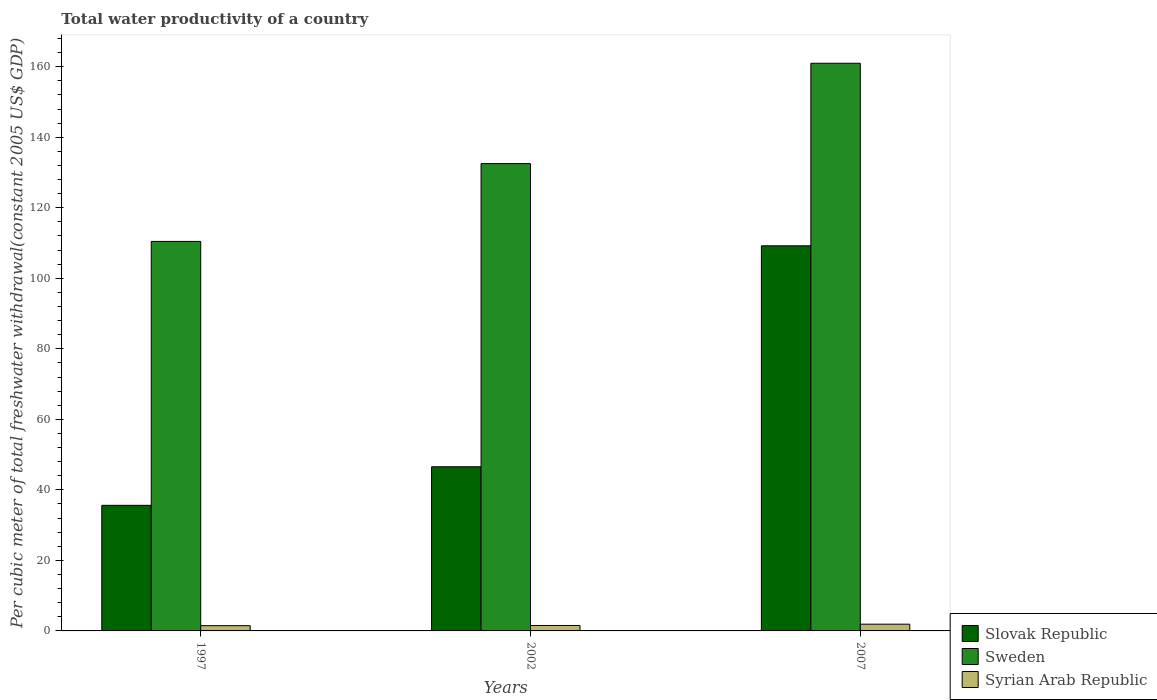How many different coloured bars are there?
Provide a short and direct response. 3. Are the number of bars on each tick of the X-axis equal?
Your answer should be compact. Yes. How many bars are there on the 1st tick from the left?
Ensure brevity in your answer.  3. How many bars are there on the 3rd tick from the right?
Make the answer very short. 3. What is the label of the 2nd group of bars from the left?
Your answer should be very brief. 2002. In how many cases, is the number of bars for a given year not equal to the number of legend labels?
Your answer should be very brief. 0. What is the total water productivity in Sweden in 2002?
Offer a very short reply. 132.53. Across all years, what is the maximum total water productivity in Slovak Republic?
Offer a terse response. 109.22. Across all years, what is the minimum total water productivity in Syrian Arab Republic?
Make the answer very short. 1.49. In which year was the total water productivity in Sweden maximum?
Your response must be concise. 2007. In which year was the total water productivity in Sweden minimum?
Your answer should be compact. 1997. What is the total total water productivity in Slovak Republic in the graph?
Your response must be concise. 191.39. What is the difference between the total water productivity in Slovak Republic in 1997 and that in 2007?
Ensure brevity in your answer.  -73.6. What is the difference between the total water productivity in Syrian Arab Republic in 1997 and the total water productivity in Sweden in 2002?
Your answer should be compact. -131.04. What is the average total water productivity in Syrian Arab Republic per year?
Your response must be concise. 1.65. In the year 2002, what is the difference between the total water productivity in Slovak Republic and total water productivity in Sweden?
Provide a short and direct response. -85.98. In how many years, is the total water productivity in Syrian Arab Republic greater than 80 US$?
Provide a short and direct response. 0. What is the ratio of the total water productivity in Slovak Republic in 1997 to that in 2002?
Make the answer very short. 0.77. Is the total water productivity in Slovak Republic in 1997 less than that in 2007?
Provide a short and direct response. Yes. Is the difference between the total water productivity in Slovak Republic in 1997 and 2002 greater than the difference between the total water productivity in Sweden in 1997 and 2002?
Provide a short and direct response. Yes. What is the difference between the highest and the second highest total water productivity in Syrian Arab Republic?
Keep it short and to the point. 0.37. What is the difference between the highest and the lowest total water productivity in Sweden?
Offer a terse response. 50.53. Is the sum of the total water productivity in Slovak Republic in 2002 and 2007 greater than the maximum total water productivity in Syrian Arab Republic across all years?
Make the answer very short. Yes. What does the 3rd bar from the right in 1997 represents?
Provide a succinct answer. Slovak Republic. How many years are there in the graph?
Provide a succinct answer. 3. What is the difference between two consecutive major ticks on the Y-axis?
Keep it short and to the point. 20. Are the values on the major ticks of Y-axis written in scientific E-notation?
Your answer should be very brief. No. Does the graph contain any zero values?
Ensure brevity in your answer.  No. Does the graph contain grids?
Keep it short and to the point. No. Where does the legend appear in the graph?
Your response must be concise. Bottom right. What is the title of the graph?
Offer a terse response. Total water productivity of a country. What is the label or title of the Y-axis?
Keep it short and to the point. Per cubic meter of total freshwater withdrawal(constant 2005 US$ GDP). What is the Per cubic meter of total freshwater withdrawal(constant 2005 US$ GDP) in Slovak Republic in 1997?
Make the answer very short. 35.62. What is the Per cubic meter of total freshwater withdrawal(constant 2005 US$ GDP) in Sweden in 1997?
Offer a very short reply. 110.46. What is the Per cubic meter of total freshwater withdrawal(constant 2005 US$ GDP) in Syrian Arab Republic in 1997?
Your answer should be compact. 1.49. What is the Per cubic meter of total freshwater withdrawal(constant 2005 US$ GDP) of Slovak Republic in 2002?
Your answer should be very brief. 46.55. What is the Per cubic meter of total freshwater withdrawal(constant 2005 US$ GDP) in Sweden in 2002?
Your answer should be very brief. 132.53. What is the Per cubic meter of total freshwater withdrawal(constant 2005 US$ GDP) of Syrian Arab Republic in 2002?
Ensure brevity in your answer.  1.54. What is the Per cubic meter of total freshwater withdrawal(constant 2005 US$ GDP) in Slovak Republic in 2007?
Your response must be concise. 109.22. What is the Per cubic meter of total freshwater withdrawal(constant 2005 US$ GDP) in Sweden in 2007?
Your response must be concise. 160.99. What is the Per cubic meter of total freshwater withdrawal(constant 2005 US$ GDP) in Syrian Arab Republic in 2007?
Keep it short and to the point. 1.91. Across all years, what is the maximum Per cubic meter of total freshwater withdrawal(constant 2005 US$ GDP) in Slovak Republic?
Give a very brief answer. 109.22. Across all years, what is the maximum Per cubic meter of total freshwater withdrawal(constant 2005 US$ GDP) of Sweden?
Keep it short and to the point. 160.99. Across all years, what is the maximum Per cubic meter of total freshwater withdrawal(constant 2005 US$ GDP) of Syrian Arab Republic?
Your answer should be compact. 1.91. Across all years, what is the minimum Per cubic meter of total freshwater withdrawal(constant 2005 US$ GDP) of Slovak Republic?
Offer a terse response. 35.62. Across all years, what is the minimum Per cubic meter of total freshwater withdrawal(constant 2005 US$ GDP) in Sweden?
Offer a very short reply. 110.46. Across all years, what is the minimum Per cubic meter of total freshwater withdrawal(constant 2005 US$ GDP) of Syrian Arab Republic?
Make the answer very short. 1.49. What is the total Per cubic meter of total freshwater withdrawal(constant 2005 US$ GDP) in Slovak Republic in the graph?
Your answer should be very brief. 191.39. What is the total Per cubic meter of total freshwater withdrawal(constant 2005 US$ GDP) of Sweden in the graph?
Your answer should be compact. 403.99. What is the total Per cubic meter of total freshwater withdrawal(constant 2005 US$ GDP) of Syrian Arab Republic in the graph?
Make the answer very short. 4.95. What is the difference between the Per cubic meter of total freshwater withdrawal(constant 2005 US$ GDP) in Slovak Republic in 1997 and that in 2002?
Give a very brief answer. -10.94. What is the difference between the Per cubic meter of total freshwater withdrawal(constant 2005 US$ GDP) of Sweden in 1997 and that in 2002?
Make the answer very short. -22.07. What is the difference between the Per cubic meter of total freshwater withdrawal(constant 2005 US$ GDP) in Syrian Arab Republic in 1997 and that in 2002?
Offer a terse response. -0.05. What is the difference between the Per cubic meter of total freshwater withdrawal(constant 2005 US$ GDP) in Slovak Republic in 1997 and that in 2007?
Offer a terse response. -73.6. What is the difference between the Per cubic meter of total freshwater withdrawal(constant 2005 US$ GDP) of Sweden in 1997 and that in 2007?
Provide a succinct answer. -50.53. What is the difference between the Per cubic meter of total freshwater withdrawal(constant 2005 US$ GDP) in Syrian Arab Republic in 1997 and that in 2007?
Your response must be concise. -0.42. What is the difference between the Per cubic meter of total freshwater withdrawal(constant 2005 US$ GDP) in Slovak Republic in 2002 and that in 2007?
Offer a very short reply. -62.66. What is the difference between the Per cubic meter of total freshwater withdrawal(constant 2005 US$ GDP) in Sweden in 2002 and that in 2007?
Offer a terse response. -28.46. What is the difference between the Per cubic meter of total freshwater withdrawal(constant 2005 US$ GDP) in Syrian Arab Republic in 2002 and that in 2007?
Ensure brevity in your answer.  -0.37. What is the difference between the Per cubic meter of total freshwater withdrawal(constant 2005 US$ GDP) in Slovak Republic in 1997 and the Per cubic meter of total freshwater withdrawal(constant 2005 US$ GDP) in Sweden in 2002?
Give a very brief answer. -96.91. What is the difference between the Per cubic meter of total freshwater withdrawal(constant 2005 US$ GDP) in Slovak Republic in 1997 and the Per cubic meter of total freshwater withdrawal(constant 2005 US$ GDP) in Syrian Arab Republic in 2002?
Provide a short and direct response. 34.07. What is the difference between the Per cubic meter of total freshwater withdrawal(constant 2005 US$ GDP) in Sweden in 1997 and the Per cubic meter of total freshwater withdrawal(constant 2005 US$ GDP) in Syrian Arab Republic in 2002?
Ensure brevity in your answer.  108.92. What is the difference between the Per cubic meter of total freshwater withdrawal(constant 2005 US$ GDP) in Slovak Republic in 1997 and the Per cubic meter of total freshwater withdrawal(constant 2005 US$ GDP) in Sweden in 2007?
Your answer should be compact. -125.37. What is the difference between the Per cubic meter of total freshwater withdrawal(constant 2005 US$ GDP) of Slovak Republic in 1997 and the Per cubic meter of total freshwater withdrawal(constant 2005 US$ GDP) of Syrian Arab Republic in 2007?
Your answer should be very brief. 33.71. What is the difference between the Per cubic meter of total freshwater withdrawal(constant 2005 US$ GDP) in Sweden in 1997 and the Per cubic meter of total freshwater withdrawal(constant 2005 US$ GDP) in Syrian Arab Republic in 2007?
Offer a very short reply. 108.55. What is the difference between the Per cubic meter of total freshwater withdrawal(constant 2005 US$ GDP) in Slovak Republic in 2002 and the Per cubic meter of total freshwater withdrawal(constant 2005 US$ GDP) in Sweden in 2007?
Ensure brevity in your answer.  -114.43. What is the difference between the Per cubic meter of total freshwater withdrawal(constant 2005 US$ GDP) in Slovak Republic in 2002 and the Per cubic meter of total freshwater withdrawal(constant 2005 US$ GDP) in Syrian Arab Republic in 2007?
Keep it short and to the point. 44.64. What is the difference between the Per cubic meter of total freshwater withdrawal(constant 2005 US$ GDP) in Sweden in 2002 and the Per cubic meter of total freshwater withdrawal(constant 2005 US$ GDP) in Syrian Arab Republic in 2007?
Make the answer very short. 130.62. What is the average Per cubic meter of total freshwater withdrawal(constant 2005 US$ GDP) of Slovak Republic per year?
Keep it short and to the point. 63.8. What is the average Per cubic meter of total freshwater withdrawal(constant 2005 US$ GDP) in Sweden per year?
Provide a succinct answer. 134.66. What is the average Per cubic meter of total freshwater withdrawal(constant 2005 US$ GDP) in Syrian Arab Republic per year?
Offer a very short reply. 1.65. In the year 1997, what is the difference between the Per cubic meter of total freshwater withdrawal(constant 2005 US$ GDP) of Slovak Republic and Per cubic meter of total freshwater withdrawal(constant 2005 US$ GDP) of Sweden?
Give a very brief answer. -74.85. In the year 1997, what is the difference between the Per cubic meter of total freshwater withdrawal(constant 2005 US$ GDP) of Slovak Republic and Per cubic meter of total freshwater withdrawal(constant 2005 US$ GDP) of Syrian Arab Republic?
Provide a short and direct response. 34.13. In the year 1997, what is the difference between the Per cubic meter of total freshwater withdrawal(constant 2005 US$ GDP) in Sweden and Per cubic meter of total freshwater withdrawal(constant 2005 US$ GDP) in Syrian Arab Republic?
Keep it short and to the point. 108.97. In the year 2002, what is the difference between the Per cubic meter of total freshwater withdrawal(constant 2005 US$ GDP) of Slovak Republic and Per cubic meter of total freshwater withdrawal(constant 2005 US$ GDP) of Sweden?
Your answer should be compact. -85.98. In the year 2002, what is the difference between the Per cubic meter of total freshwater withdrawal(constant 2005 US$ GDP) of Slovak Republic and Per cubic meter of total freshwater withdrawal(constant 2005 US$ GDP) of Syrian Arab Republic?
Keep it short and to the point. 45.01. In the year 2002, what is the difference between the Per cubic meter of total freshwater withdrawal(constant 2005 US$ GDP) of Sweden and Per cubic meter of total freshwater withdrawal(constant 2005 US$ GDP) of Syrian Arab Republic?
Make the answer very short. 130.99. In the year 2007, what is the difference between the Per cubic meter of total freshwater withdrawal(constant 2005 US$ GDP) of Slovak Republic and Per cubic meter of total freshwater withdrawal(constant 2005 US$ GDP) of Sweden?
Give a very brief answer. -51.77. In the year 2007, what is the difference between the Per cubic meter of total freshwater withdrawal(constant 2005 US$ GDP) in Slovak Republic and Per cubic meter of total freshwater withdrawal(constant 2005 US$ GDP) in Syrian Arab Republic?
Your response must be concise. 107.31. In the year 2007, what is the difference between the Per cubic meter of total freshwater withdrawal(constant 2005 US$ GDP) in Sweden and Per cubic meter of total freshwater withdrawal(constant 2005 US$ GDP) in Syrian Arab Republic?
Your answer should be very brief. 159.08. What is the ratio of the Per cubic meter of total freshwater withdrawal(constant 2005 US$ GDP) in Slovak Republic in 1997 to that in 2002?
Offer a very short reply. 0.77. What is the ratio of the Per cubic meter of total freshwater withdrawal(constant 2005 US$ GDP) in Sweden in 1997 to that in 2002?
Make the answer very short. 0.83. What is the ratio of the Per cubic meter of total freshwater withdrawal(constant 2005 US$ GDP) of Syrian Arab Republic in 1997 to that in 2002?
Give a very brief answer. 0.97. What is the ratio of the Per cubic meter of total freshwater withdrawal(constant 2005 US$ GDP) in Slovak Republic in 1997 to that in 2007?
Ensure brevity in your answer.  0.33. What is the ratio of the Per cubic meter of total freshwater withdrawal(constant 2005 US$ GDP) of Sweden in 1997 to that in 2007?
Your answer should be very brief. 0.69. What is the ratio of the Per cubic meter of total freshwater withdrawal(constant 2005 US$ GDP) in Syrian Arab Republic in 1997 to that in 2007?
Provide a short and direct response. 0.78. What is the ratio of the Per cubic meter of total freshwater withdrawal(constant 2005 US$ GDP) of Slovak Republic in 2002 to that in 2007?
Offer a terse response. 0.43. What is the ratio of the Per cubic meter of total freshwater withdrawal(constant 2005 US$ GDP) of Sweden in 2002 to that in 2007?
Your answer should be very brief. 0.82. What is the ratio of the Per cubic meter of total freshwater withdrawal(constant 2005 US$ GDP) in Syrian Arab Republic in 2002 to that in 2007?
Make the answer very short. 0.81. What is the difference between the highest and the second highest Per cubic meter of total freshwater withdrawal(constant 2005 US$ GDP) in Slovak Republic?
Give a very brief answer. 62.66. What is the difference between the highest and the second highest Per cubic meter of total freshwater withdrawal(constant 2005 US$ GDP) of Sweden?
Give a very brief answer. 28.46. What is the difference between the highest and the second highest Per cubic meter of total freshwater withdrawal(constant 2005 US$ GDP) in Syrian Arab Republic?
Offer a terse response. 0.37. What is the difference between the highest and the lowest Per cubic meter of total freshwater withdrawal(constant 2005 US$ GDP) in Slovak Republic?
Make the answer very short. 73.6. What is the difference between the highest and the lowest Per cubic meter of total freshwater withdrawal(constant 2005 US$ GDP) in Sweden?
Provide a short and direct response. 50.53. What is the difference between the highest and the lowest Per cubic meter of total freshwater withdrawal(constant 2005 US$ GDP) in Syrian Arab Republic?
Make the answer very short. 0.42. 